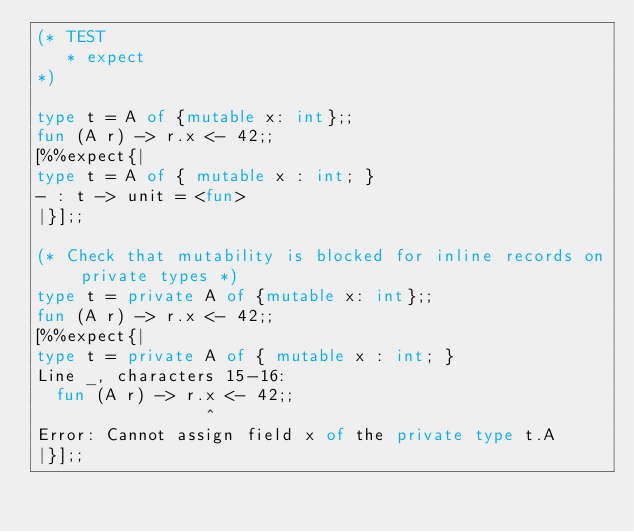<code> <loc_0><loc_0><loc_500><loc_500><_OCaml_>(* TEST
   * expect
*)

type t = A of {mutable x: int};;
fun (A r) -> r.x <- 42;;
[%%expect{|
type t = A of { mutable x : int; }
- : t -> unit = <fun>
|}];;

(* Check that mutability is blocked for inline records on private types *)
type t = private A of {mutable x: int};;
fun (A r) -> r.x <- 42;;
[%%expect{|
type t = private A of { mutable x : int; }
Line _, characters 15-16:
  fun (A r) -> r.x <- 42;;
                 ^
Error: Cannot assign field x of the private type t.A
|}];;
</code> 